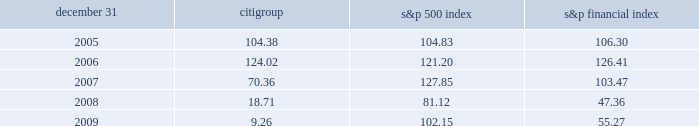Comparison of five-year cumulative total return the following graph compares the cumulative total return on citigroup 2019s common stock with the s&p 500 index and the s&p financial index over the five-year period extending through december 31 , 2009 .
The graph assumes that $ 100 was invested on december 31 , 2004 in citigroup 2019s common stock , the s&p 500 index and the s&p financial index and that all dividends were reinvested .
Citigroup s&p 500 index s&p financial index 2005 2006 2007 2008 2009 comparison of five-year cumulative total return for the years ended .

What was the ratio of cumulative total return for citigroup compared to the s&p 500 index in 2007? 
Rationale: in 2007 total return for citigroup compared was $ 0.55 for each $ 1 of the the s&p 500 index
Computations: (70.36 / 127.85)
Answer: 0.55033. Comparison of five-year cumulative total return the following graph compares the cumulative total return on citigroup 2019s common stock with the s&p 500 index and the s&p financial index over the five-year period extending through december 31 , 2009 .
The graph assumes that $ 100 was invested on december 31 , 2004 in citigroup 2019s common stock , the s&p 500 index and the s&p financial index and that all dividends were reinvested .
Citigroup s&p 500 index s&p financial index 2005 2006 2007 2008 2009 comparison of five-year cumulative total return for the years ended .

What was the difference in percent cumulative total return on citigroup's common stock compared to the s&p 500 index for five year period ended 2009? 
Computations: (((9.26 - 100) / 100) - ((102.15 - 100) / 100))
Answer: -0.9289. Comparison of five-year cumulative total return the following graph compares the cumulative total return on citigroup 2019s common stock with the s&p 500 index and the s&p financial index over the five-year period extending through december 31 , 2009 .
The graph assumes that $ 100 was invested on december 31 , 2004 in citigroup 2019s common stock , the s&p 500 index and the s&p financial index and that all dividends were reinvested .
Citigroup s&p 500 index s&p financial index 2005 2006 2007 2008 2009 comparison of five-year cumulative total return for the years ended .

What was the percent cumulative total return on citigroup's common stock for five year period ended 2009? 
Computations: ((9.26 - 100) / 100)
Answer: -0.9074. 